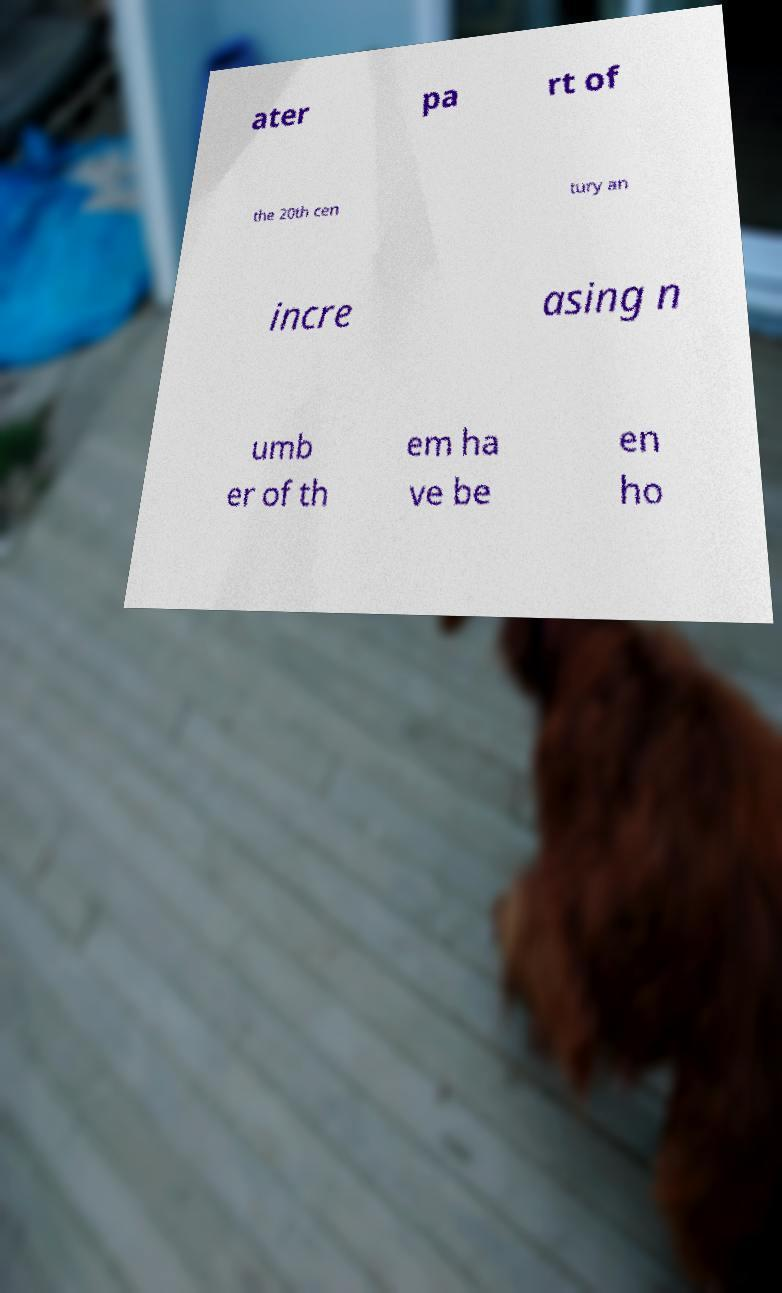Can you read and provide the text displayed in the image?This photo seems to have some interesting text. Can you extract and type it out for me? ater pa rt of the 20th cen tury an incre asing n umb er of th em ha ve be en ho 